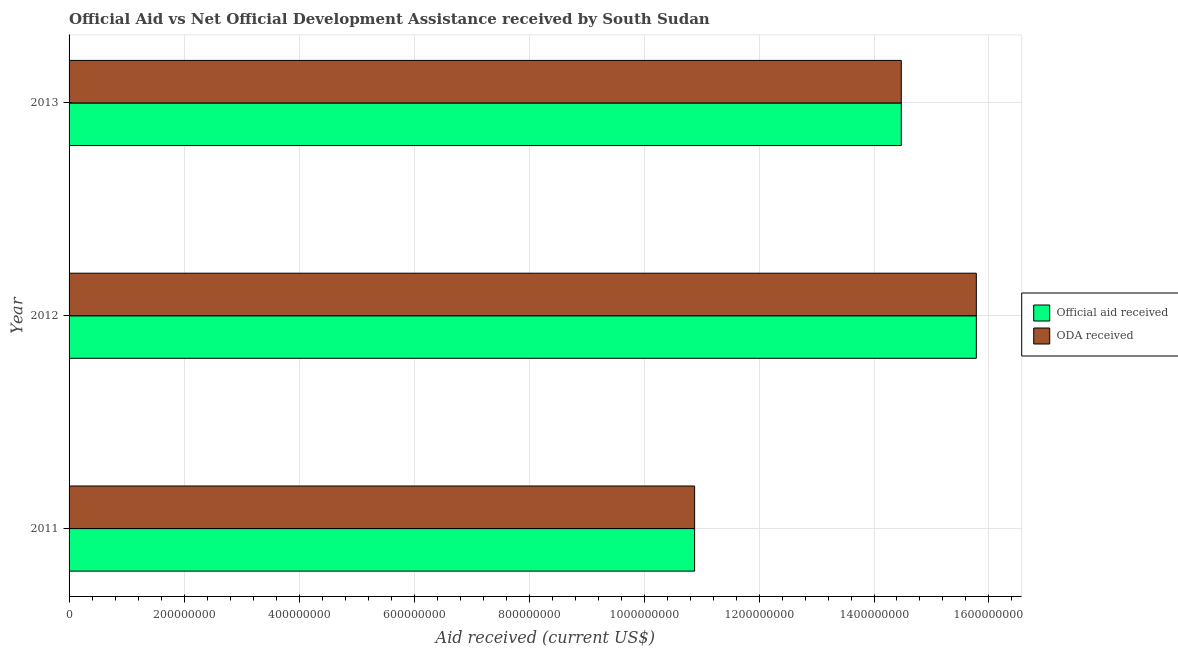Are the number of bars per tick equal to the number of legend labels?
Your response must be concise. Yes. Are the number of bars on each tick of the Y-axis equal?
Your answer should be compact. Yes. How many bars are there on the 3rd tick from the top?
Ensure brevity in your answer.  2. What is the label of the 2nd group of bars from the top?
Your answer should be very brief. 2012. In how many cases, is the number of bars for a given year not equal to the number of legend labels?
Make the answer very short. 0. What is the oda received in 2011?
Offer a very short reply. 1.09e+09. Across all years, what is the maximum official aid received?
Your answer should be compact. 1.58e+09. Across all years, what is the minimum oda received?
Your answer should be very brief. 1.09e+09. In which year was the oda received maximum?
Your response must be concise. 2012. In which year was the official aid received minimum?
Make the answer very short. 2011. What is the total official aid received in the graph?
Ensure brevity in your answer.  4.11e+09. What is the difference between the official aid received in 2012 and that in 2013?
Your answer should be very brief. 1.31e+08. What is the difference between the oda received in 2013 and the official aid received in 2011?
Provide a short and direct response. 3.59e+08. What is the average official aid received per year?
Provide a succinct answer. 1.37e+09. In the year 2012, what is the difference between the oda received and official aid received?
Offer a terse response. 0. In how many years, is the official aid received greater than 1080000000 US$?
Make the answer very short. 3. What is the ratio of the official aid received in 2011 to that in 2012?
Keep it short and to the point. 0.69. Is the oda received in 2011 less than that in 2012?
Your response must be concise. Yes. Is the difference between the oda received in 2011 and 2013 greater than the difference between the official aid received in 2011 and 2013?
Offer a terse response. No. What is the difference between the highest and the second highest oda received?
Provide a short and direct response. 1.31e+08. What is the difference between the highest and the lowest oda received?
Make the answer very short. 4.90e+08. In how many years, is the oda received greater than the average oda received taken over all years?
Make the answer very short. 2. Is the sum of the official aid received in 2012 and 2013 greater than the maximum oda received across all years?
Your answer should be very brief. Yes. What does the 2nd bar from the top in 2012 represents?
Keep it short and to the point. Official aid received. What does the 1st bar from the bottom in 2011 represents?
Give a very brief answer. Official aid received. How many bars are there?
Your answer should be very brief. 6. Are all the bars in the graph horizontal?
Your answer should be very brief. Yes. What is the difference between two consecutive major ticks on the X-axis?
Offer a very short reply. 2.00e+08. Does the graph contain any zero values?
Make the answer very short. No. Does the graph contain grids?
Give a very brief answer. Yes. Where does the legend appear in the graph?
Provide a succinct answer. Center right. How many legend labels are there?
Your answer should be very brief. 2. What is the title of the graph?
Provide a short and direct response. Official Aid vs Net Official Development Assistance received by South Sudan . What is the label or title of the X-axis?
Your answer should be very brief. Aid received (current US$). What is the label or title of the Y-axis?
Your answer should be compact. Year. What is the Aid received (current US$) in Official aid received in 2011?
Your response must be concise. 1.09e+09. What is the Aid received (current US$) of ODA received in 2011?
Give a very brief answer. 1.09e+09. What is the Aid received (current US$) in Official aid received in 2012?
Offer a terse response. 1.58e+09. What is the Aid received (current US$) in ODA received in 2012?
Give a very brief answer. 1.58e+09. What is the Aid received (current US$) in Official aid received in 2013?
Give a very brief answer. 1.45e+09. What is the Aid received (current US$) in ODA received in 2013?
Give a very brief answer. 1.45e+09. Across all years, what is the maximum Aid received (current US$) in Official aid received?
Your answer should be very brief. 1.58e+09. Across all years, what is the maximum Aid received (current US$) in ODA received?
Offer a very short reply. 1.58e+09. Across all years, what is the minimum Aid received (current US$) of Official aid received?
Your response must be concise. 1.09e+09. Across all years, what is the minimum Aid received (current US$) in ODA received?
Make the answer very short. 1.09e+09. What is the total Aid received (current US$) in Official aid received in the graph?
Provide a short and direct response. 4.11e+09. What is the total Aid received (current US$) in ODA received in the graph?
Give a very brief answer. 4.11e+09. What is the difference between the Aid received (current US$) in Official aid received in 2011 and that in 2012?
Your answer should be compact. -4.90e+08. What is the difference between the Aid received (current US$) of ODA received in 2011 and that in 2012?
Offer a terse response. -4.90e+08. What is the difference between the Aid received (current US$) in Official aid received in 2011 and that in 2013?
Offer a very short reply. -3.59e+08. What is the difference between the Aid received (current US$) of ODA received in 2011 and that in 2013?
Provide a succinct answer. -3.59e+08. What is the difference between the Aid received (current US$) in Official aid received in 2012 and that in 2013?
Your response must be concise. 1.31e+08. What is the difference between the Aid received (current US$) of ODA received in 2012 and that in 2013?
Your answer should be very brief. 1.31e+08. What is the difference between the Aid received (current US$) in Official aid received in 2011 and the Aid received (current US$) in ODA received in 2012?
Make the answer very short. -4.90e+08. What is the difference between the Aid received (current US$) of Official aid received in 2011 and the Aid received (current US$) of ODA received in 2013?
Ensure brevity in your answer.  -3.59e+08. What is the difference between the Aid received (current US$) in Official aid received in 2012 and the Aid received (current US$) in ODA received in 2013?
Provide a short and direct response. 1.31e+08. What is the average Aid received (current US$) of Official aid received per year?
Your answer should be compact. 1.37e+09. What is the average Aid received (current US$) of ODA received per year?
Keep it short and to the point. 1.37e+09. In the year 2013, what is the difference between the Aid received (current US$) of Official aid received and Aid received (current US$) of ODA received?
Your answer should be very brief. 0. What is the ratio of the Aid received (current US$) of Official aid received in 2011 to that in 2012?
Make the answer very short. 0.69. What is the ratio of the Aid received (current US$) of ODA received in 2011 to that in 2012?
Give a very brief answer. 0.69. What is the ratio of the Aid received (current US$) of Official aid received in 2011 to that in 2013?
Provide a short and direct response. 0.75. What is the ratio of the Aid received (current US$) in ODA received in 2011 to that in 2013?
Offer a very short reply. 0.75. What is the ratio of the Aid received (current US$) in Official aid received in 2012 to that in 2013?
Keep it short and to the point. 1.09. What is the ratio of the Aid received (current US$) of ODA received in 2012 to that in 2013?
Provide a succinct answer. 1.09. What is the difference between the highest and the second highest Aid received (current US$) in Official aid received?
Your answer should be compact. 1.31e+08. What is the difference between the highest and the second highest Aid received (current US$) of ODA received?
Your response must be concise. 1.31e+08. What is the difference between the highest and the lowest Aid received (current US$) of Official aid received?
Keep it short and to the point. 4.90e+08. What is the difference between the highest and the lowest Aid received (current US$) of ODA received?
Provide a succinct answer. 4.90e+08. 